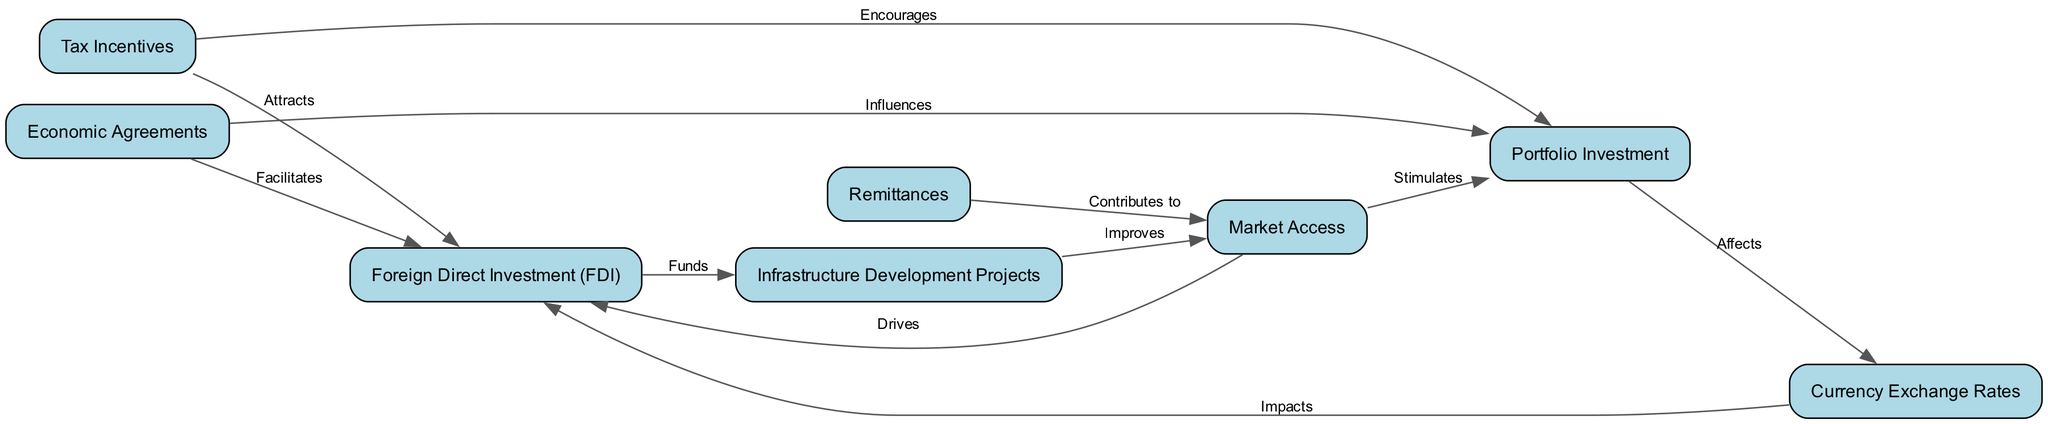What is the primary type of investment depicted at the top of the diagram? The diagram begins with "Foreign Direct Investment (FDI)" which is placed at the top, indicating that it is the primary type of investment being represented.
Answer: Foreign Direct Investment (FDI) How many elements are shown in the diagram? The diagram includes a total of eight distinct elements related to capital investment, which can be counted directly from the nodes in the diagram.
Answer: Eight Which investment type affects currency exchange rates? The diagram shows "Portfolio Investment" being linked to "Currency Exchange Rates", indicating that it is the type of investment that affects exchange rates.
Answer: Portfolio Investment What relationship is indicated between Economic Agreements and Foreign Direct Investment? The diagram indicates that "Economic Agreements" facilitates "Foreign Direct Investment", establishing a direct relationship where economic agreements positively influence FDI flows.
Answer: Facilitates Which two factors drive investment decisions in the context of market access? The diagram connects "Market Access" to both "Foreign Direct Investment (FDI)" and "Portfolio Investment", showing that these are driven by the ability to access and compete in foreign markets.
Answer: Drives What type of investment is influenced by Tax Incentives according to the diagram? The diagram illustrates how "Tax Incentives" are linked to both "Foreign Direct Investment (FDI)" and "Portfolio Investment," suggesting they encourage these two types of investments.
Answer: Both Foreign Direct Investment (FDI) and Portfolio Investment How do infrastructure development projects improve market access? The diagram illustrates that "Infrastructure Development Projects" improve "Market Access", implying that better infrastructure enables more effective entry into and competition in foreign markets.
Answer: Improves Which factor is directly impacted by currency exchange rates? The diagram indicates that "Foreign Direct Investment (FDI)" is impacted by "Currency Exchange Rates", establishing a causal influence between these two elements.
Answer: Foreign Direct Investment (FDI) 